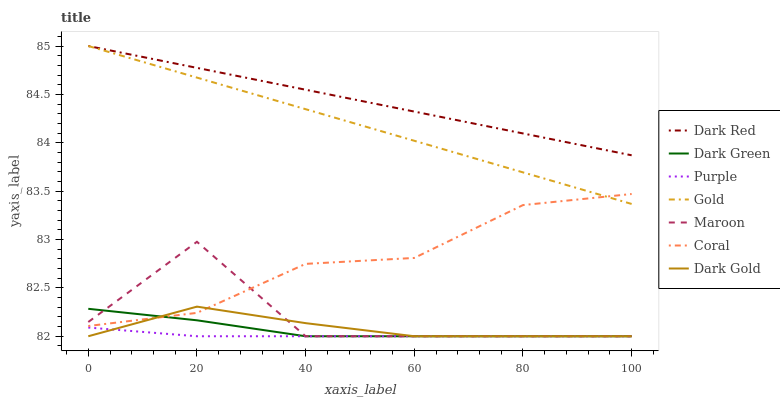Does Purple have the minimum area under the curve?
Answer yes or no. Yes. Does Dark Red have the maximum area under the curve?
Answer yes or no. Yes. Does Dark Gold have the minimum area under the curve?
Answer yes or no. No. Does Dark Gold have the maximum area under the curve?
Answer yes or no. No. Is Dark Red the smoothest?
Answer yes or no. Yes. Is Maroon the roughest?
Answer yes or no. Yes. Is Dark Gold the smoothest?
Answer yes or no. No. Is Dark Gold the roughest?
Answer yes or no. No. Does Dark Gold have the lowest value?
Answer yes or no. Yes. Does Dark Red have the lowest value?
Answer yes or no. No. Does Dark Red have the highest value?
Answer yes or no. Yes. Does Dark Gold have the highest value?
Answer yes or no. No. Is Maroon less than Gold?
Answer yes or no. Yes. Is Dark Red greater than Coral?
Answer yes or no. Yes. Does Maroon intersect Dark Gold?
Answer yes or no. Yes. Is Maroon less than Dark Gold?
Answer yes or no. No. Is Maroon greater than Dark Gold?
Answer yes or no. No. Does Maroon intersect Gold?
Answer yes or no. No. 